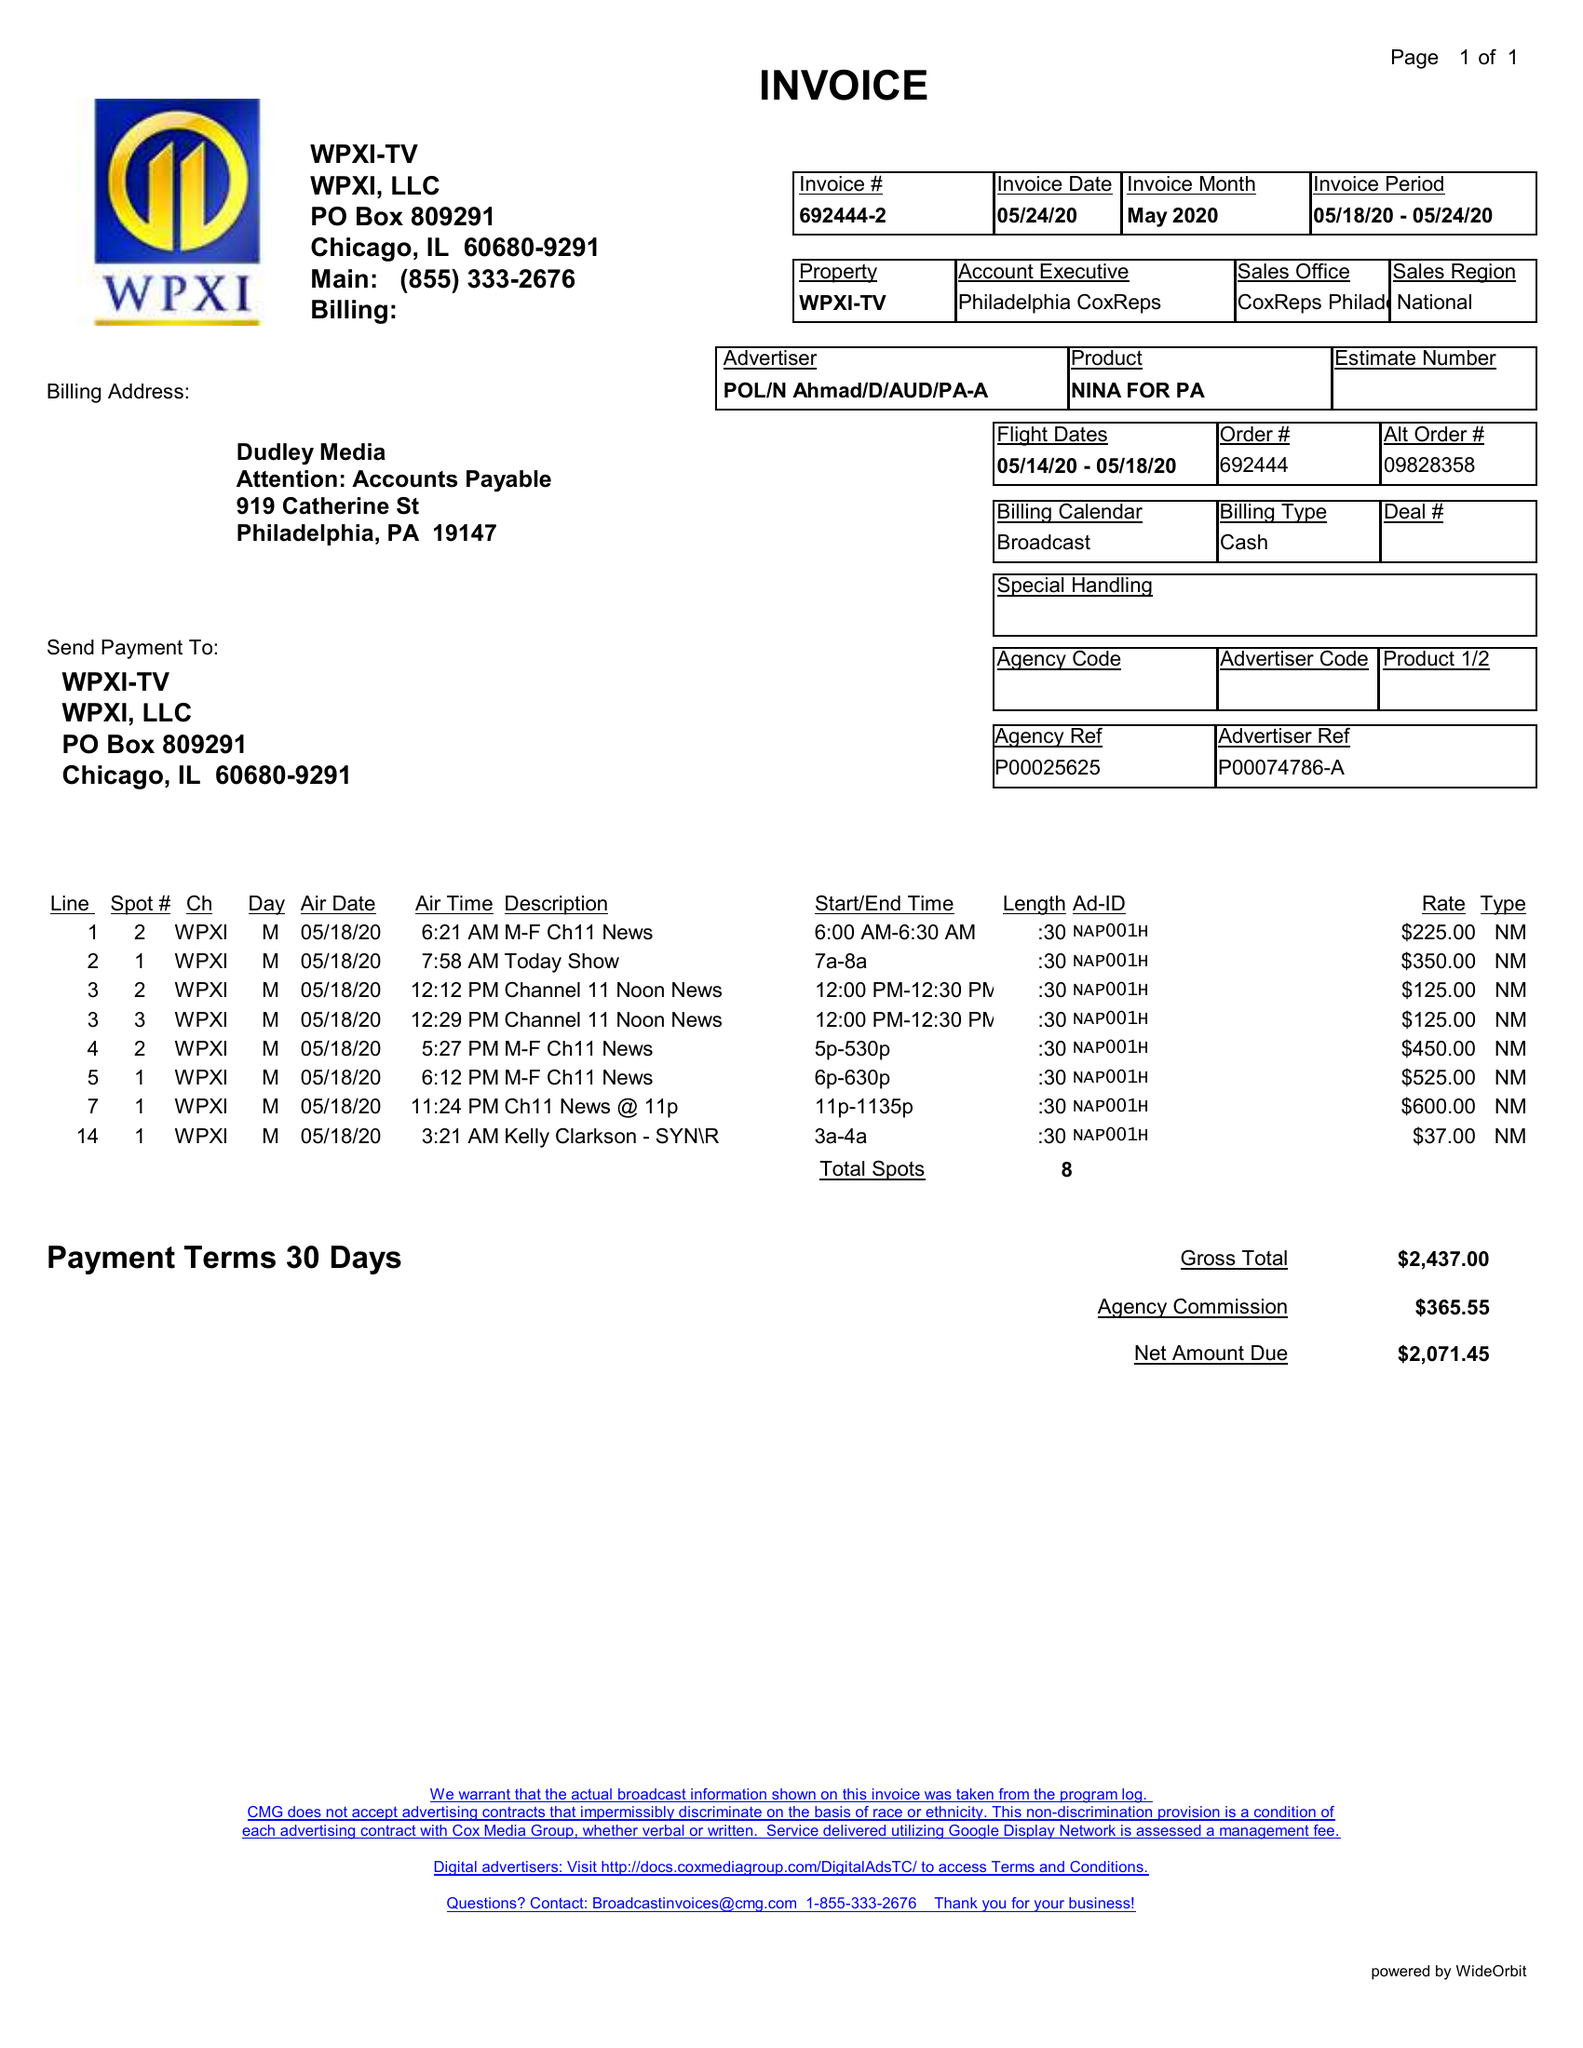What is the value for the flight_to?
Answer the question using a single word or phrase. 05/18/20 